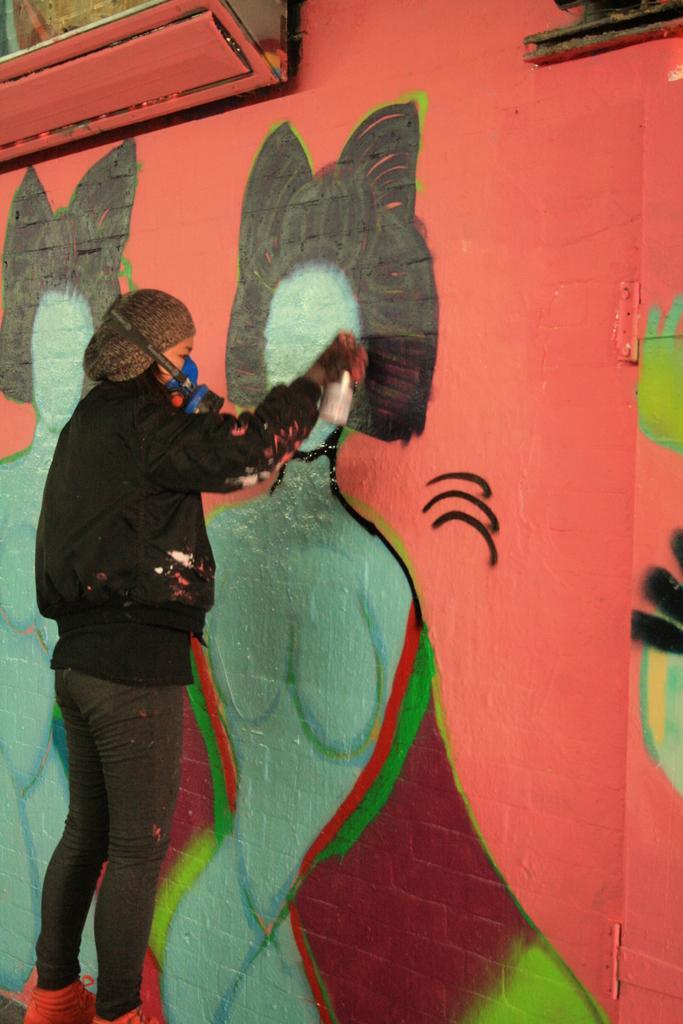How would you summarize this image in a sentence or two? In the picture there is a person painting on a wall. 